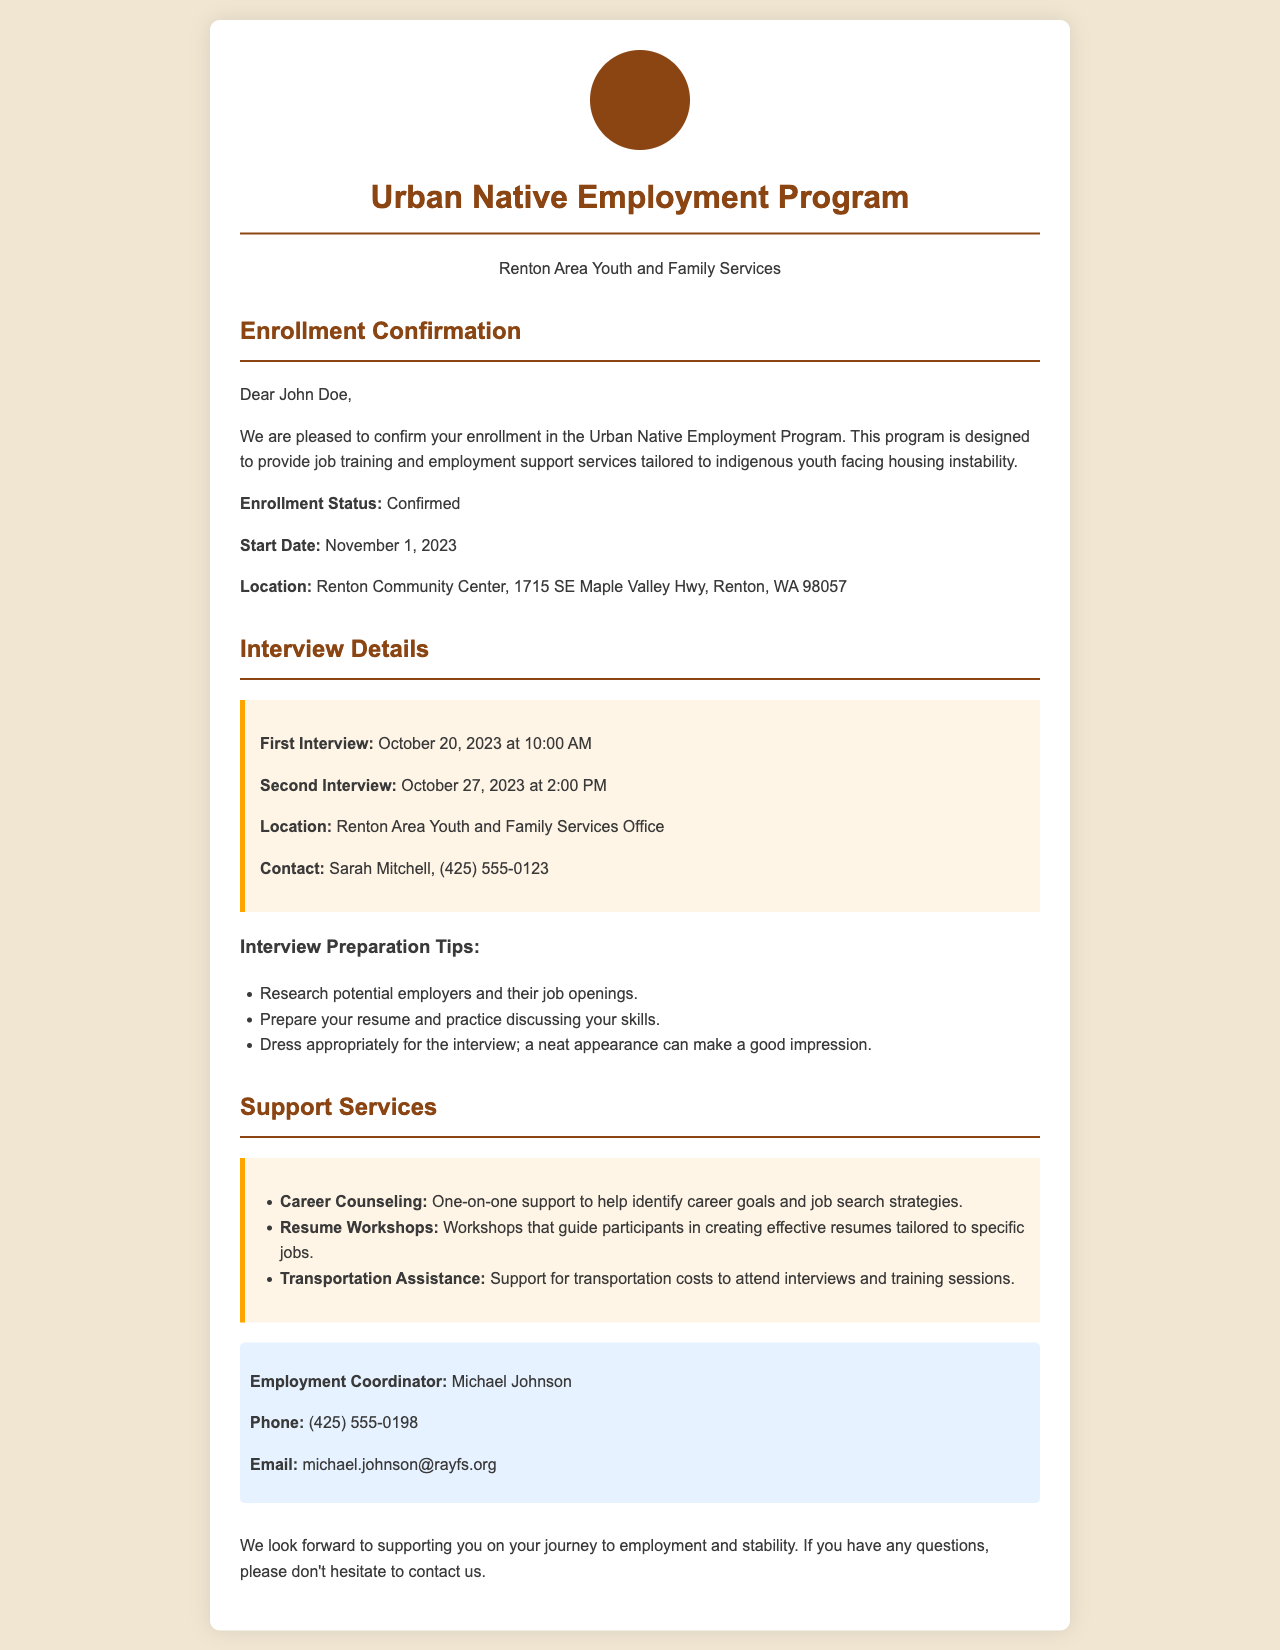What is the name of the program? The name of the program is mentioned at the top of the document as the "Urban Native Employment Program."
Answer: Urban Native Employment Program What is the enrollment status? The document explicitly states the enrollment status as "Confirmed."
Answer: Confirmed When does the program start? The start date of the program is specified in the document as November 1, 2023.
Answer: November 1, 2023 Who is the contact person for interviews? The contact person for interviews is specified as Sarah Mitchell in the interview details section.
Answer: Sarah Mitchell What is the location for the first interview? The document indicates that the first interview takes place at the Renton Area Youth and Family Services Office.
Answer: Renton Area Youth and Family Services Office What type of support does the program offer related to resumes? The document lists "Resume Workshops" as one of the support services offered by the program.
Answer: Resume Workshops How much time is there between the first and second interviews? There are seven days between the first interview on October 20 and the second interview on October 27.
Answer: Seven days What is the phone number for the Employment Coordinator? The phone number for the Employment Coordinator, Michael Johnson, is detailed in the contact info section as (425) 555-0198.
Answer: (425) 555-0198 What is a tip given for interview preparation? One of the tips for interview preparation is to "Research potential employers and their job openings."
Answer: Research potential employers and their job openings 